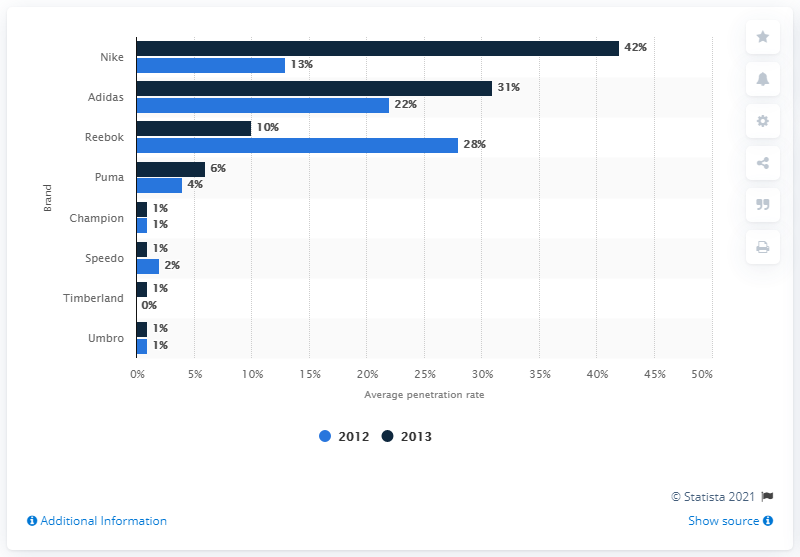Outline some significant characteristics in this image. In 2013, around 10% of the survey respondents reported purchasing Reebok brand sportswear in the last three to twelve months. 